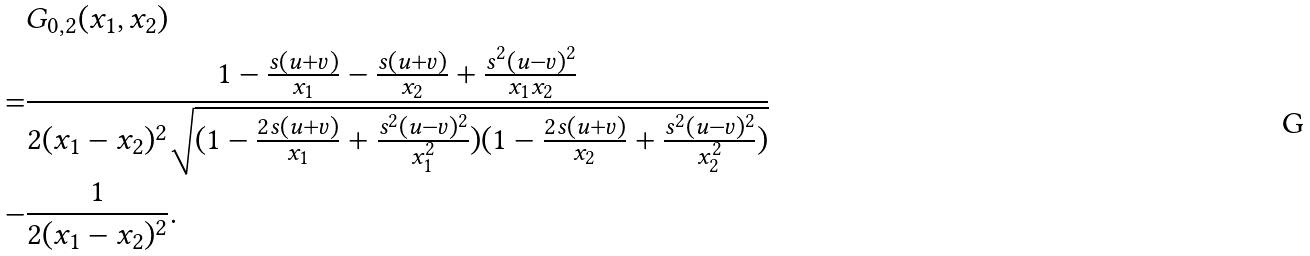<formula> <loc_0><loc_0><loc_500><loc_500>& G _ { 0 , 2 } ( x _ { 1 } , x _ { 2 } ) \\ = & \frac { 1 - \frac { s ( u + v ) } { x _ { 1 } } - \frac { s ( u + v ) } { x _ { 2 } } + \frac { s ^ { 2 } ( u - v ) ^ { 2 } } { x _ { 1 } x _ { 2 } } } { 2 ( x _ { 1 } - x _ { 2 } ) ^ { 2 } \sqrt { ( 1 - \frac { 2 s ( u + v ) } { x _ { 1 } } + \frac { s ^ { 2 } ( u - v ) ^ { 2 } } { x _ { 1 } ^ { 2 } } ) ( 1 - \frac { 2 s ( u + v ) } { x _ { 2 } } + \frac { s ^ { 2 } ( u - v ) ^ { 2 } } { x _ { 2 } ^ { 2 } } ) } } \\ - & \frac { 1 } { 2 ( x _ { 1 } - x _ { 2 } ) ^ { 2 } } .</formula> 